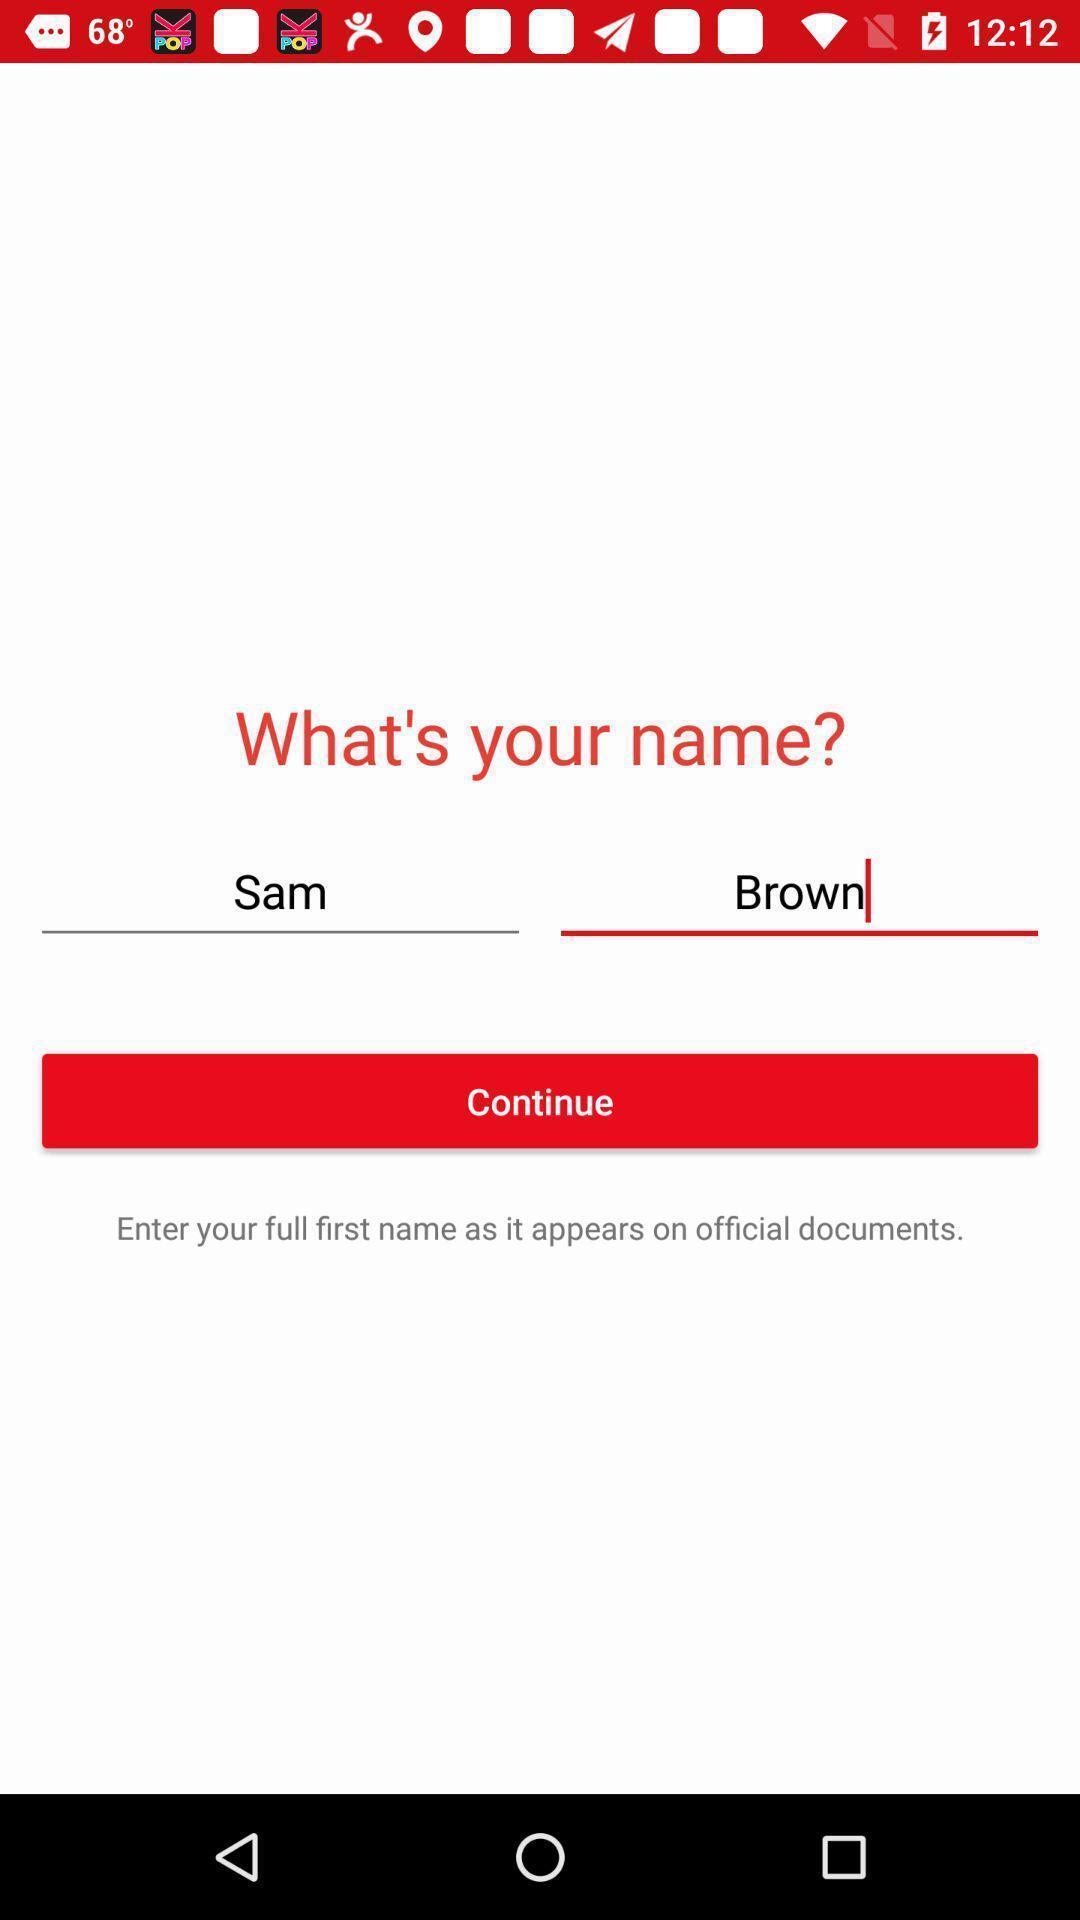Provide a detailed account of this screenshot. Page showing to enter name to continue on app. 